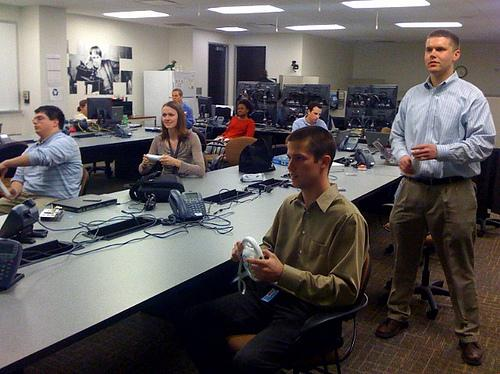What is the man in the brown shirt emulating with the white controller?

Choices:
A) driving
B) shooting
C) boxing
D) skiing driving 